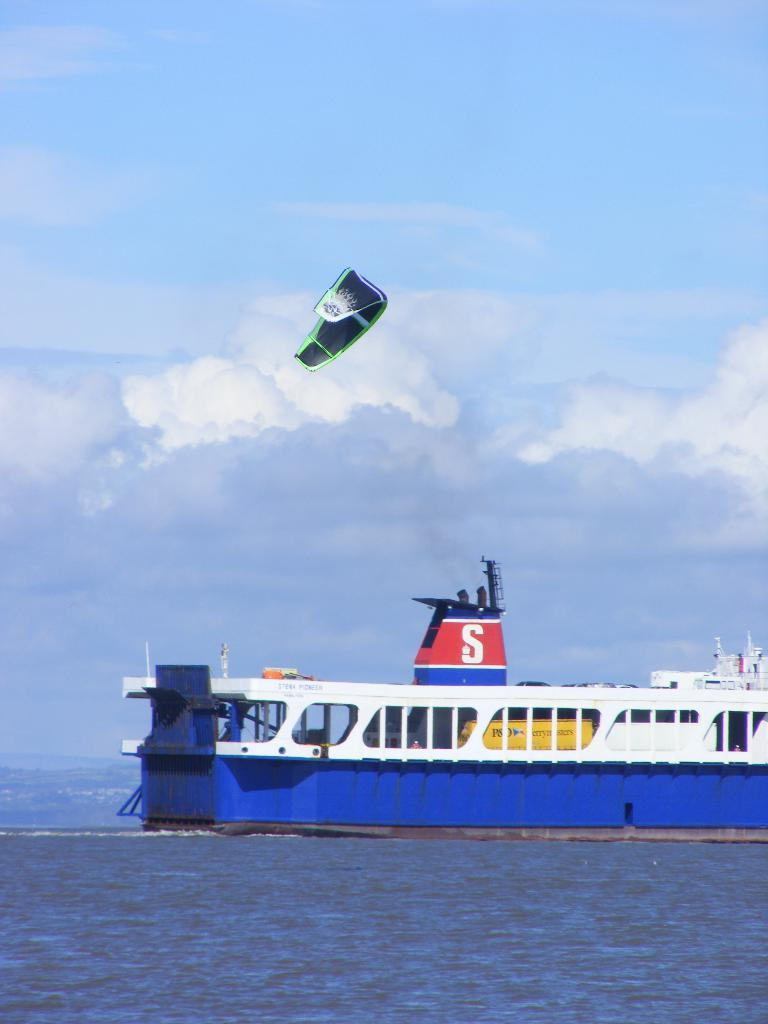What is the main subject of the image? The main subject of the image is a ship. Where is the ship located in the image? The ship is on the water in the image. What else can be seen in the sky in the background of the image? There is a parachute visible in the sky in the background of the image. What type of weather can be seen in the image? The provided facts do not mention any specific weather conditions in the image, so we cannot determine the weather from the information given. 